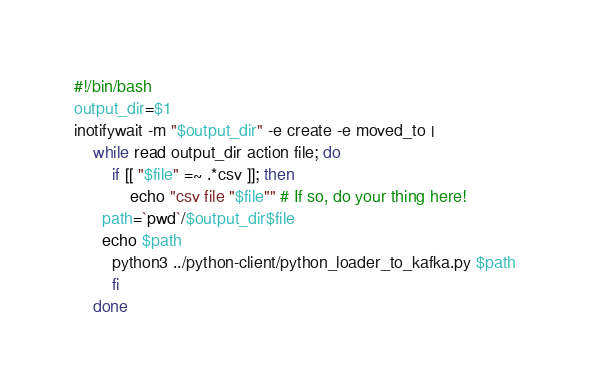Convert code to text. <code><loc_0><loc_0><loc_500><loc_500><_Bash_>#!/bin/bash
output_dir=$1
inotifywait -m "$output_dir" -e create -e moved_to |
    while read output_dir action file; do
        if [[ "$file" =~ .*csv ]]; then
            echo "csv file "$file"" # If so, do your thing here!
      path=`pwd`/$output_dir$file
      echo $path
	    python3 ../python-client/python_loader_to_kafka.py $path 
        fi
    done
</code> 